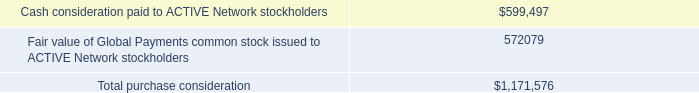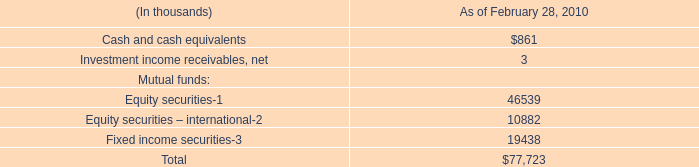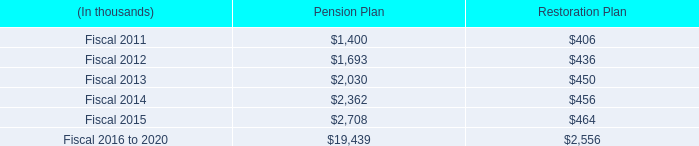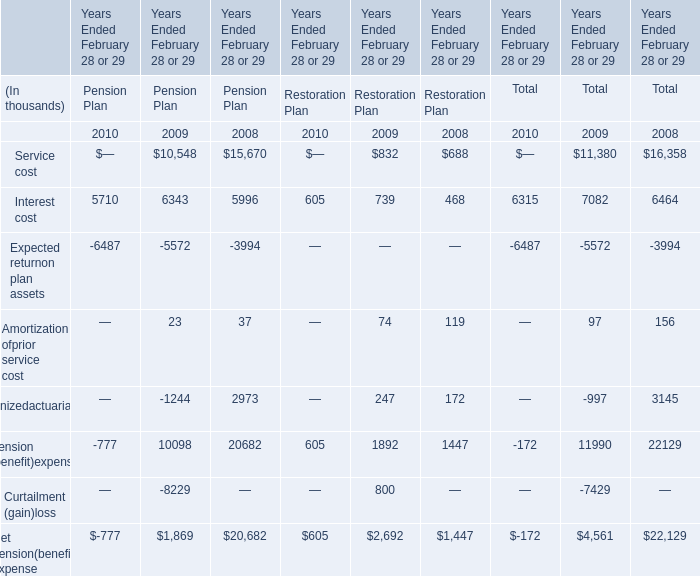Does the average value of Pension Plan in 2012 greater than that in 2011 ? 
Answer: yes. 